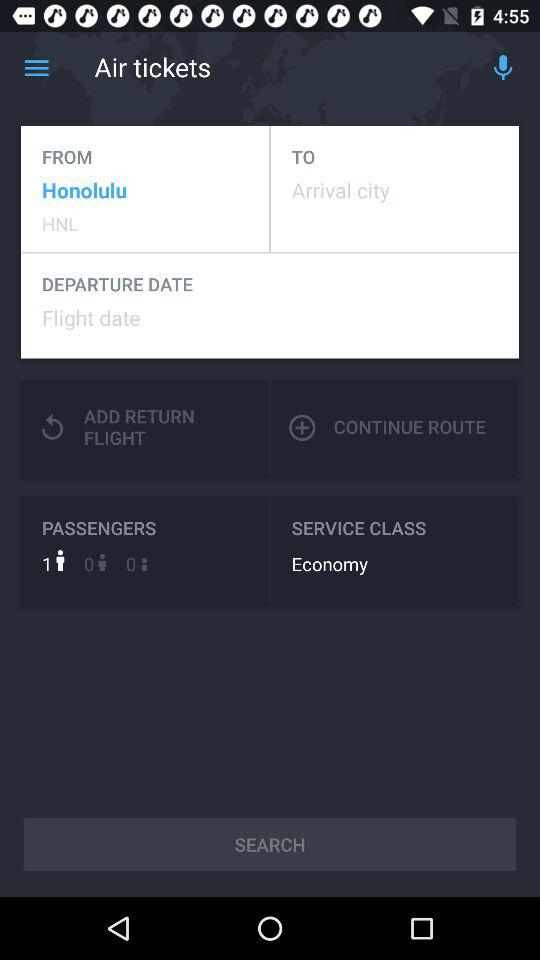What is the departure city? The departure city is Honolulu. 